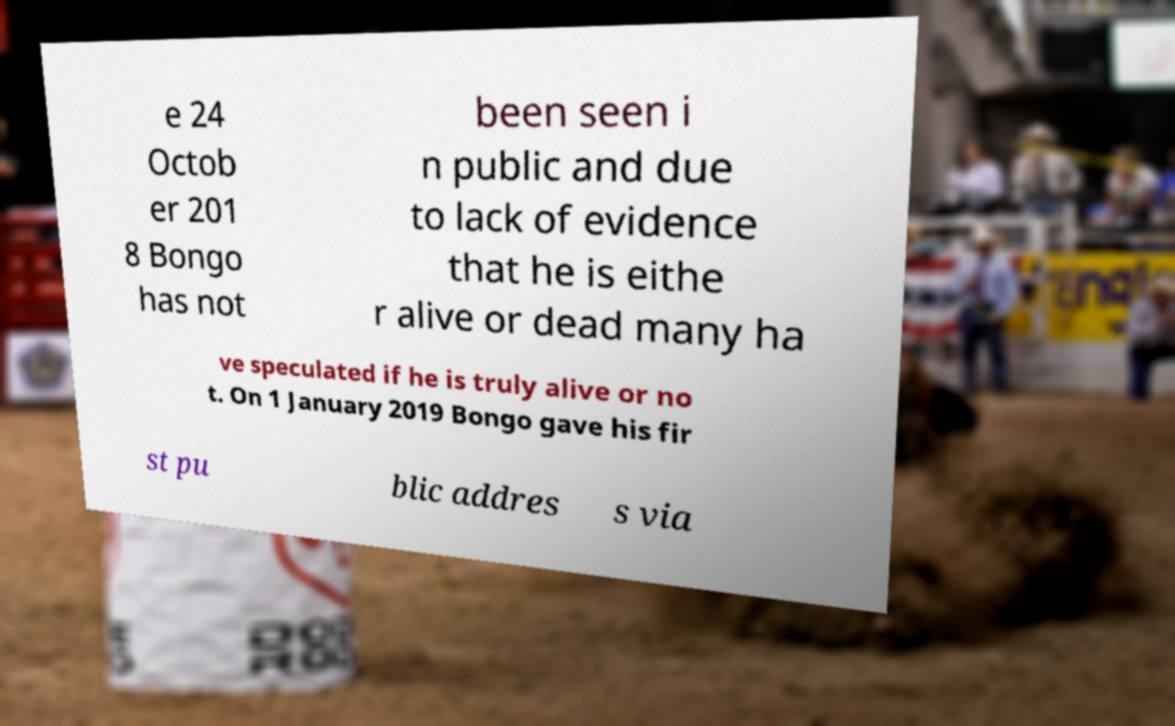Could you extract and type out the text from this image? e 24 Octob er 201 8 Bongo has not been seen i n public and due to lack of evidence that he is eithe r alive or dead many ha ve speculated if he is truly alive or no t. On 1 January 2019 Bongo gave his fir st pu blic addres s via 